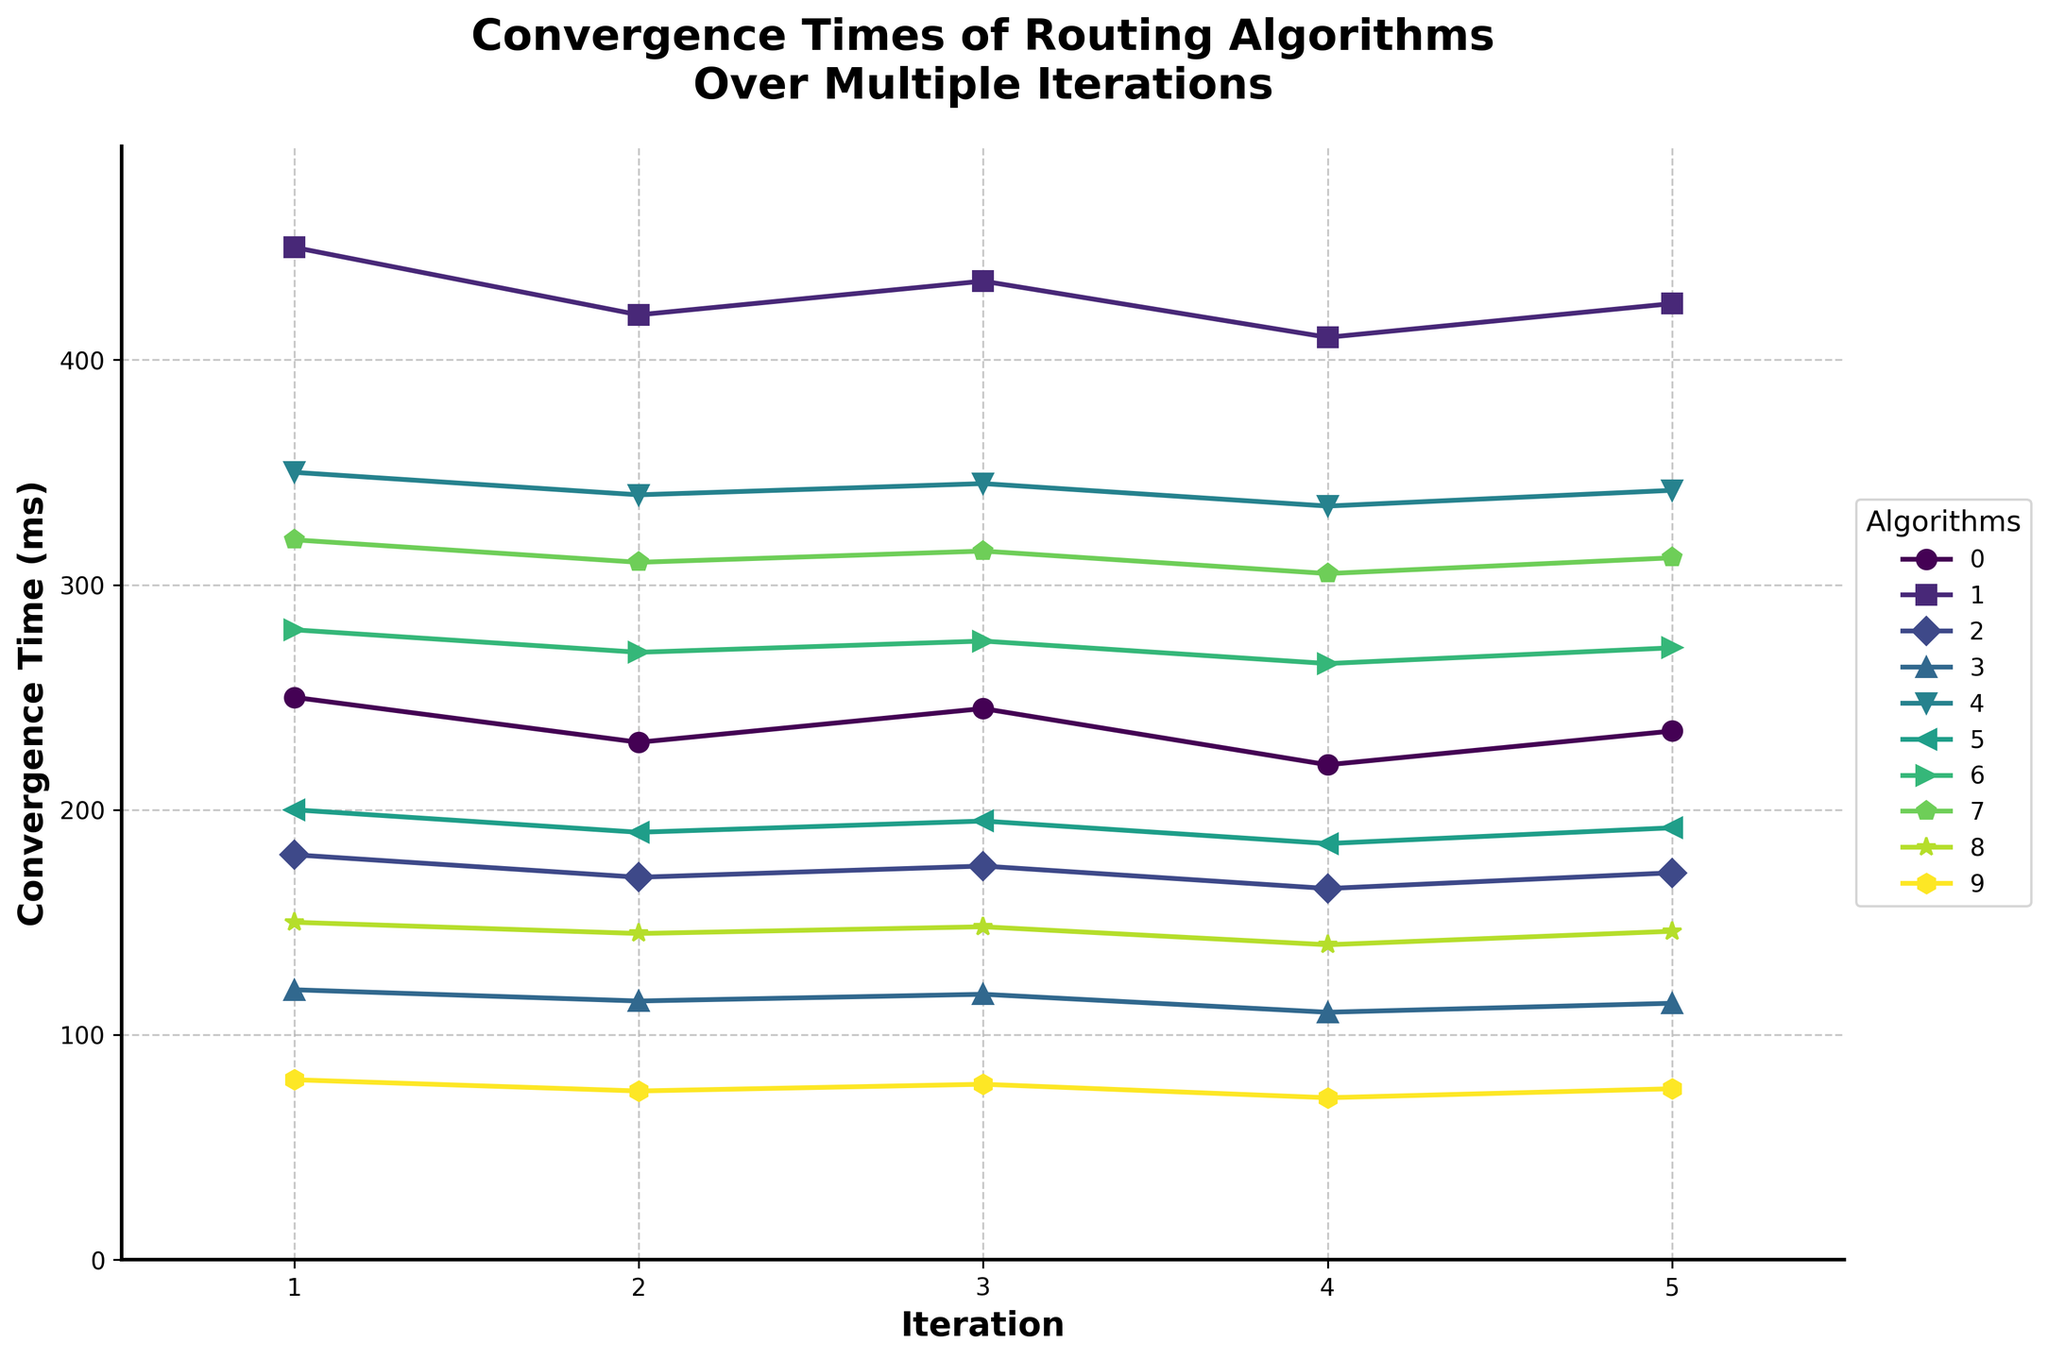Which algorithm has the fastest convergence time across all iterations? By observing the y-axis values, BFD consistently has the lowest convergence times across all iterations when compared to other algorithms.
Answer: BFD Which algorithm has the slowest convergence time in Iteration 3? In Iteration 3, BGP has the highest y-axis value among the algorithms, indicating the slowest convergence time.
Answer: BGP What is the average convergence time of OSPF across all iterations? The convergence times for OSPF are 250, 230, 245, 220, and 235. Summing these gives 1180, and dividing by 5 gives 236.
Answer: 236 Which algorithms have a convergence time below 200 ms in all iterations? From the y-axis, IS-IS, EIGRP, Segment Routing, and BFD have all convergence times below 200 ms across all iterations.
Answer: IS-IS, EIGRP, Segment Routing, BFD How does the convergence time of MPLS-TE in Iteration 5 compare to the convergence time of VXLAN BGP EVPN in Iteration 5? For Iteration 5, MPLS-TE has a y-axis value of 272 ms whereas VXLAN BGP EVPN has 312 ms. Therefore, MPLS-TE's convergence time is 40 ms lower than VXLAN BGP EVPN.
Answer: MPLS-TE is 40 ms lower Which algorithm shows the least variation in convergence times across all iterations? By observing the spread of y-axis values for each algorithm, BFD has the least variation since all values are very close.
Answer: BFD Calculate the total convergence time for RIP across all iterations. The convergence times for RIP are 350, 340, 345, 335, and 342 ms. Summing these gives 1712 ms in total.
Answer: 1712 Which iteration has the highest average convergence time across all algorithms? Calculate the average convergence time for each iteration: Iteration 1 (242.5 ms), Iteration 2 (230 ms), Iteration 3 (237.6 ms), Iteration 4 (222.2 ms), and Iteration 5 (231.3 ms). Initially we see the average is highest for Iteration 1.
Answer: Iteration 1 Compare the convergence times of OSPF and Segment Routing in Iteration 2. In Iteration 2, OSPF is at 230 ms and Segment Routing is at 145 ms. OSPF's convergence time is 85 ms higher than Segment Routing in this iteration.
Answer: OSPF is 85 ms higher 